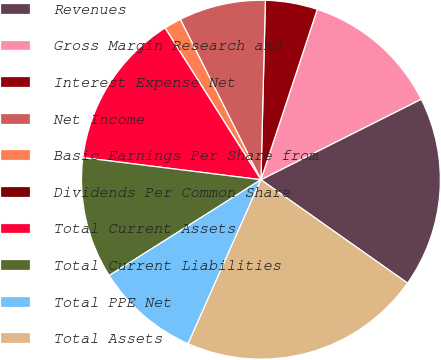<chart> <loc_0><loc_0><loc_500><loc_500><pie_chart><fcel>Revenues<fcel>Gross Margin Research and<fcel>Interest Expense Net<fcel>Net Income<fcel>Basic Earnings Per Share from<fcel>Dividends Per Common Share<fcel>Total Current Assets<fcel>Total Current Liabilities<fcel>Total PPE Net<fcel>Total Assets<nl><fcel>17.19%<fcel>12.5%<fcel>4.69%<fcel>7.81%<fcel>1.56%<fcel>0.0%<fcel>14.06%<fcel>10.94%<fcel>9.38%<fcel>21.87%<nl></chart> 